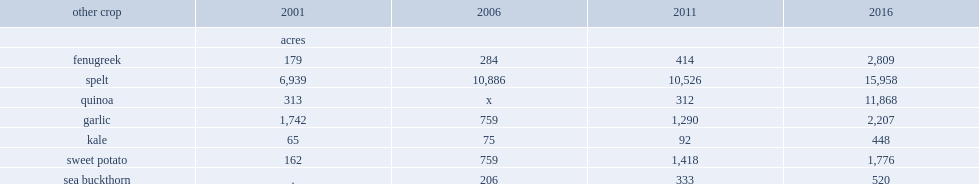How many acres of farms reporting fenugreek increase between 2001 and 2006? 105. How many acres of farms reporting fenugreek increase from 2006 to 2011? 130. How many acres of farms reporting fenugreek increase from 2011 to 2016? 2395. How many acres of crop area for farms reporting kale were increased? 17. Which year has a larger increase in the crop area for farms reporting kale, 2011 or 2006? 2011. How many acres of crop area growth did the farm reporting kale have between 2011 and 2016? 356. How many acres of crop area for sweet potates were increased between 2001 and 2006? 597. How many acres of crop area for sweet potates were increased between 2011 and 2006? 659. How many acres of crop area for sweet potates were increased from 2011 to 2016? 358. How many acres of the area under cultivation for farms reporting sea buckthorn were increased from 2006 to 2011? 127. How many acres of farms reporting sea buckthorn were increased from 2011 to 2016? 187. 